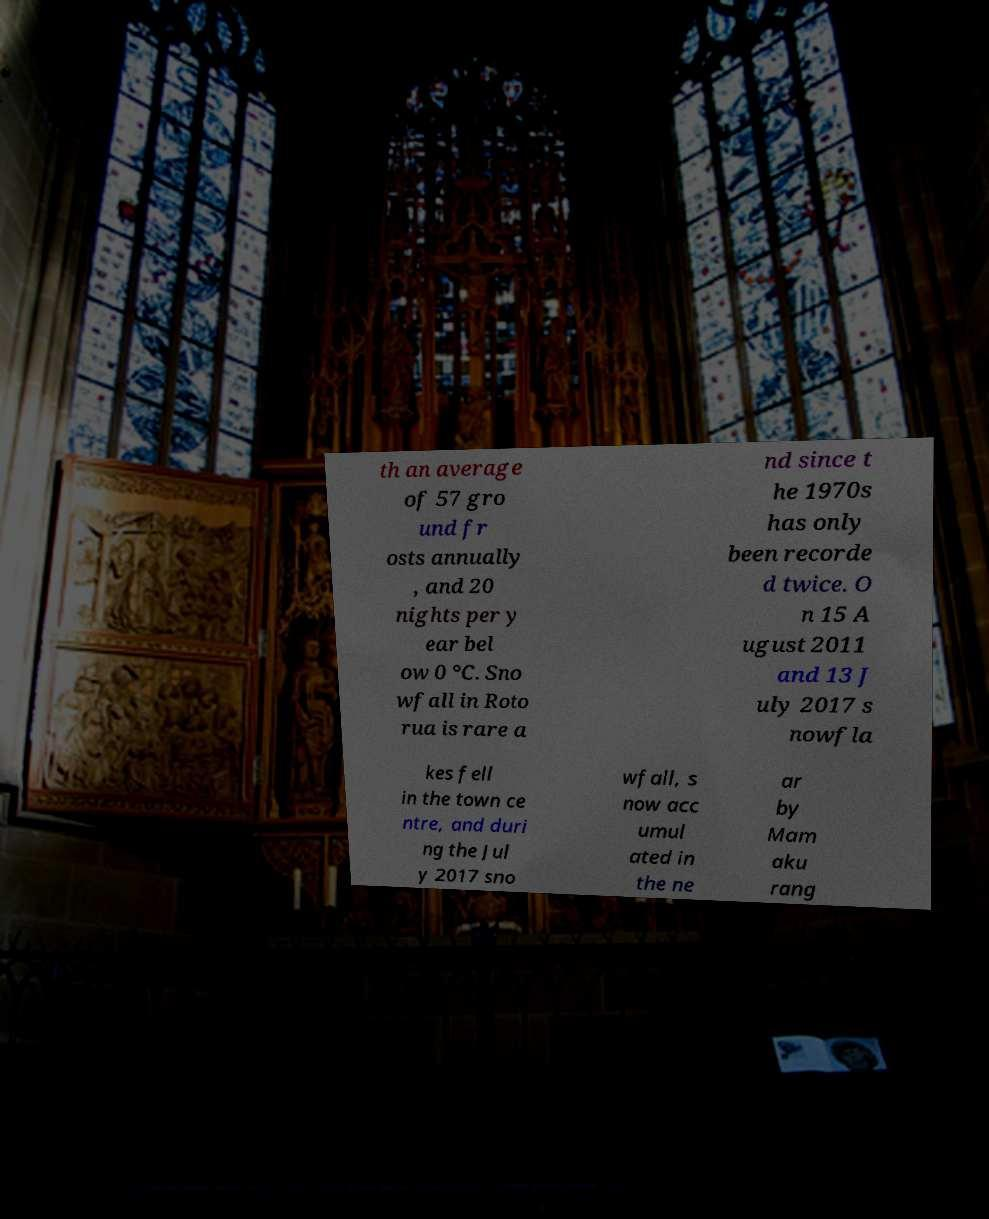Please read and relay the text visible in this image. What does it say? th an average of 57 gro und fr osts annually , and 20 nights per y ear bel ow 0 °C. Sno wfall in Roto rua is rare a nd since t he 1970s has only been recorde d twice. O n 15 A ugust 2011 and 13 J uly 2017 s nowfla kes fell in the town ce ntre, and duri ng the Jul y 2017 sno wfall, s now acc umul ated in the ne ar by Mam aku rang 